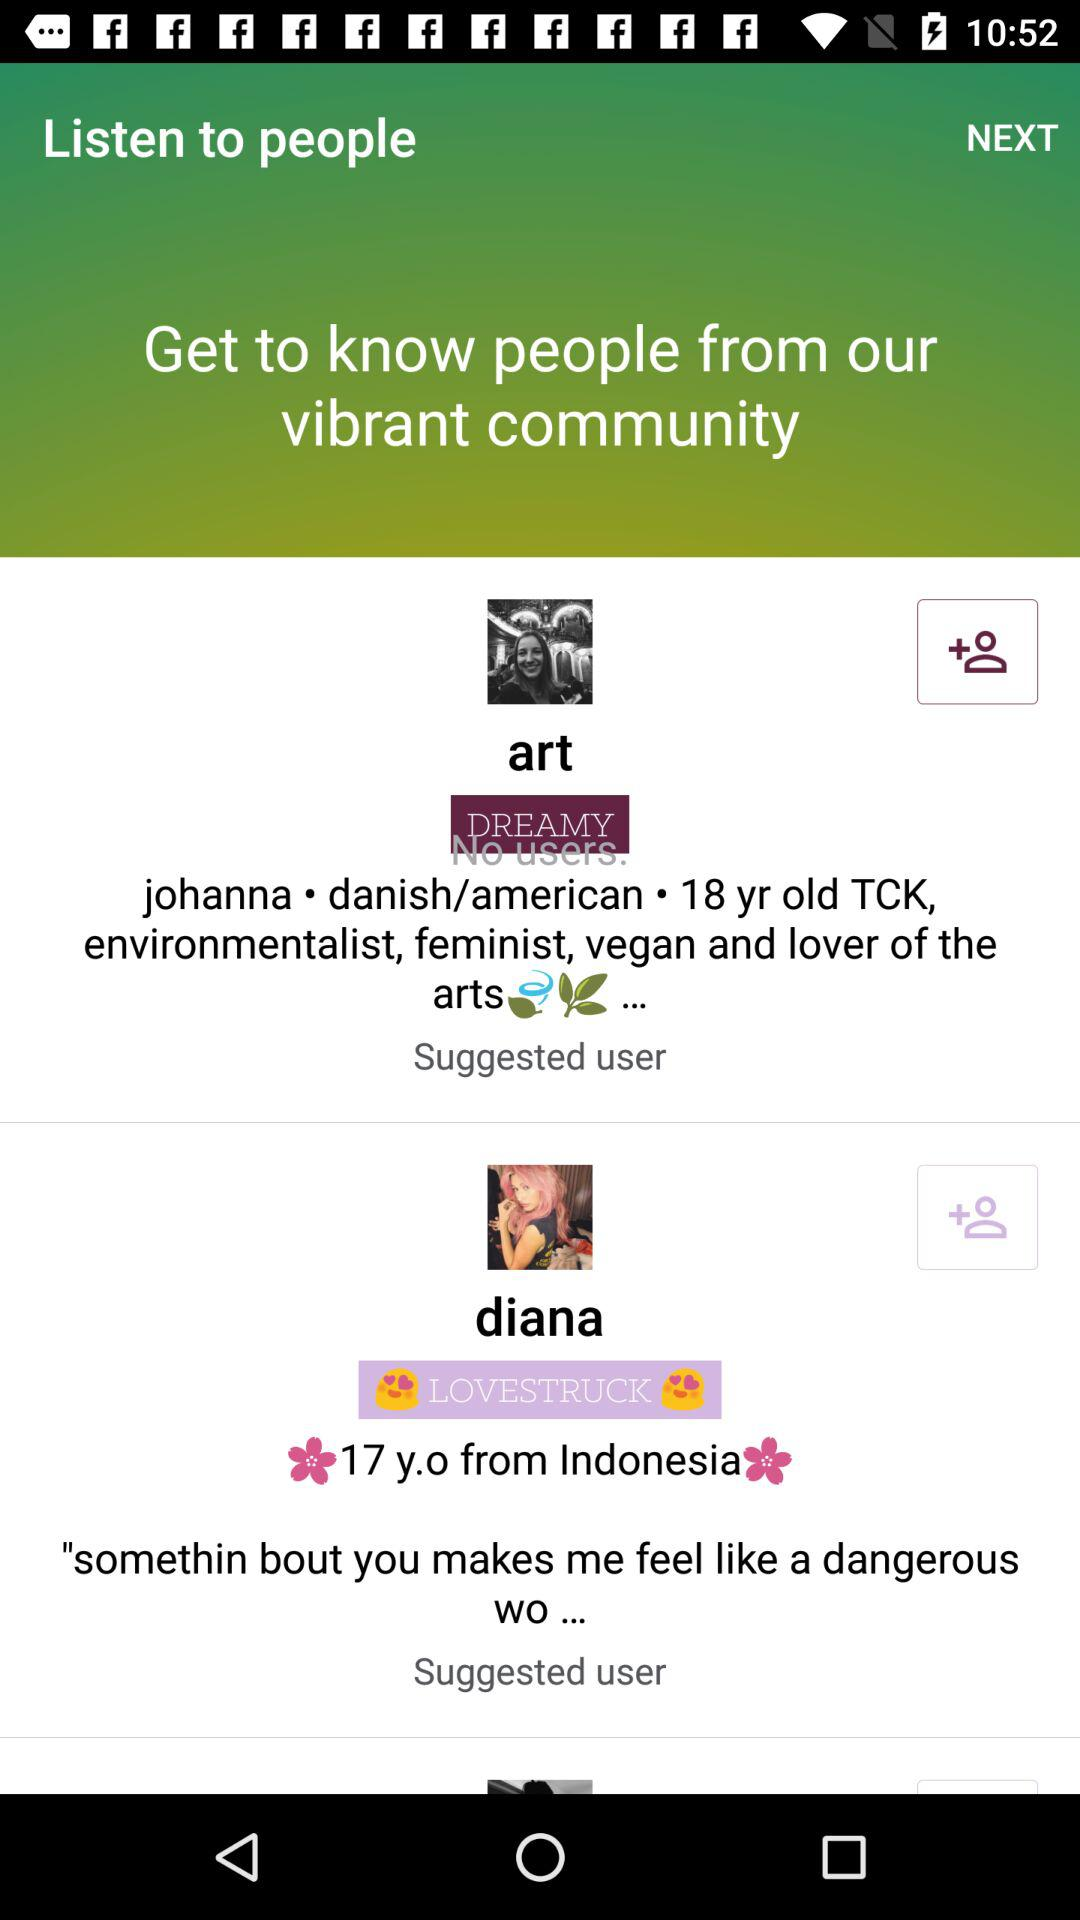What is the age of Diana? Diana is 17 years old. 